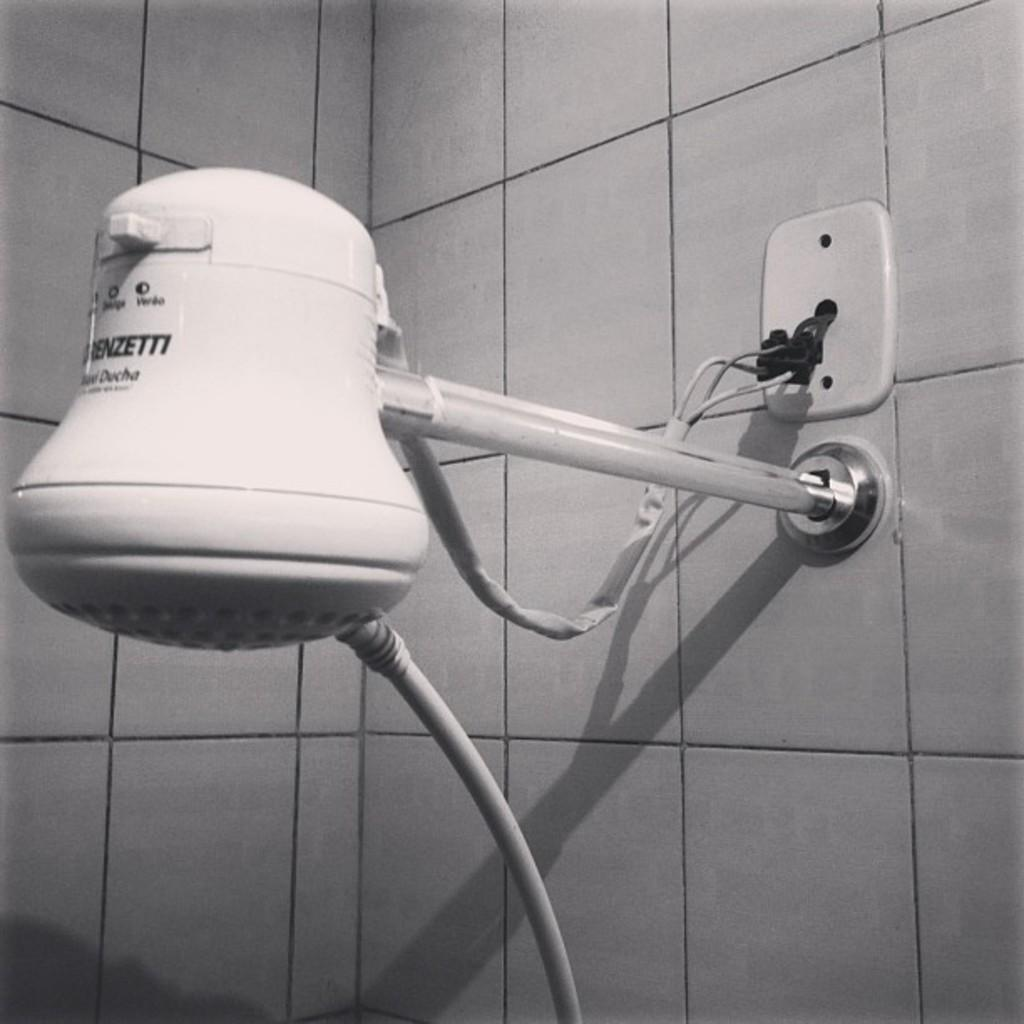What is the main object in the image? There is a shower head in the image. Where is the shower head attached to? The shower head is fitted to tiles. What type of jeans is hanging on the shower head in the image? There are no jeans present in the image; it only features a shower head fitted to tiles. 